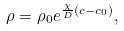Convert formula to latex. <formula><loc_0><loc_0><loc_500><loc_500>\rho = \rho _ { 0 } e ^ { \frac { \chi } { D } ( c - c _ { 0 } ) } ,</formula> 